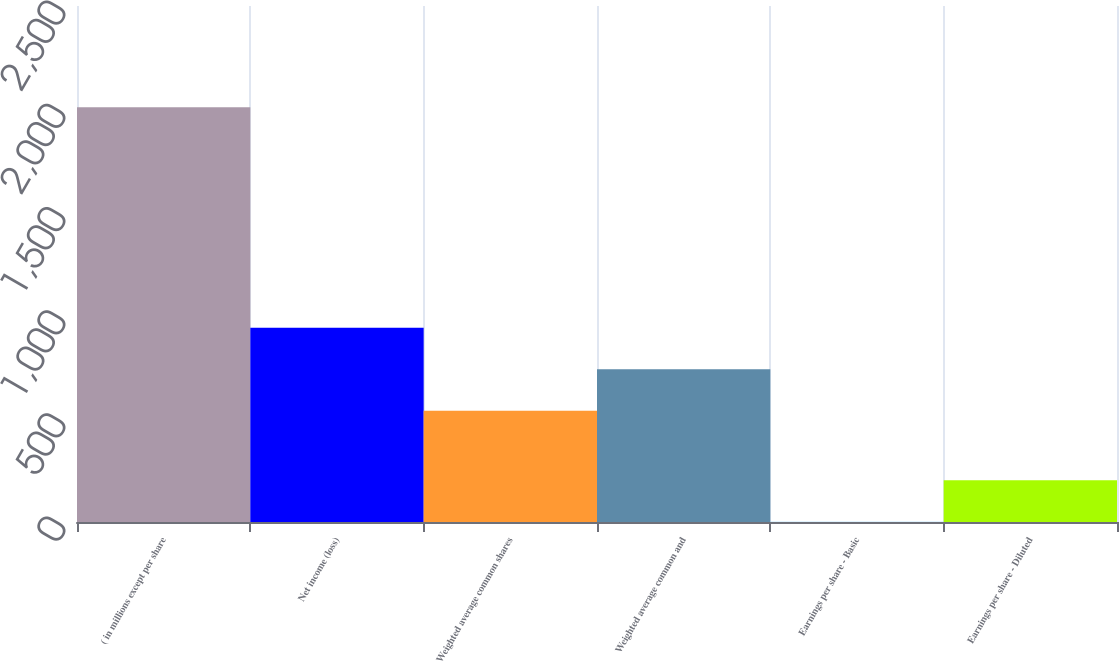Convert chart to OTSL. <chart><loc_0><loc_0><loc_500><loc_500><bar_chart><fcel>( in millions except per share<fcel>Net income (loss)<fcel>Weighted average common shares<fcel>Weighted average common and<fcel>Earnings per share - Basic<fcel>Earnings per share - Diluted<nl><fcel>2009<fcel>941.08<fcel>539.6<fcel>740.34<fcel>1.58<fcel>202.32<nl></chart> 